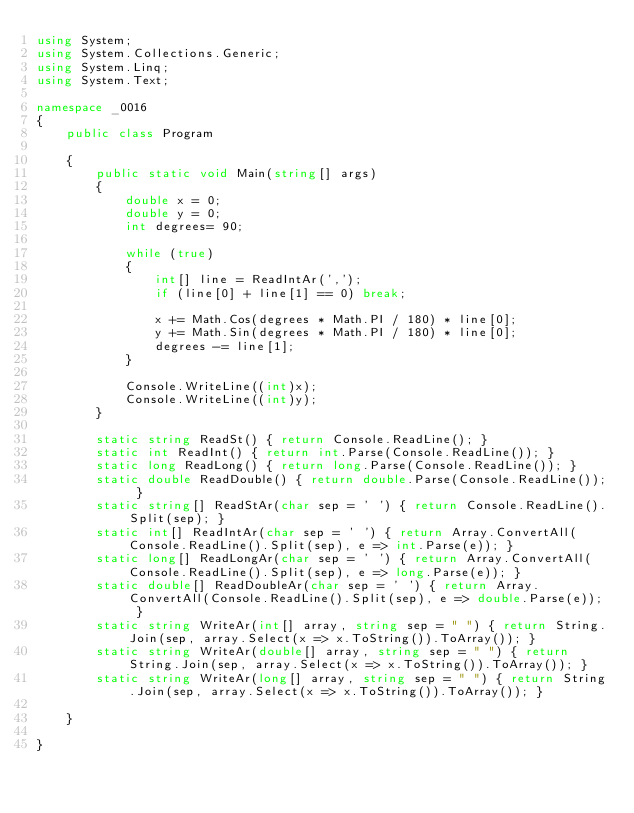<code> <loc_0><loc_0><loc_500><loc_500><_C#_>using System;
using System.Collections.Generic;
using System.Linq;
using System.Text;

namespace _0016
{
    public class Program

    {
        public static void Main(string[] args)
        {
            double x = 0;
            double y = 0;
            int degrees= 90;

            while (true)
            {
                int[] line = ReadIntAr(',');
                if (line[0] + line[1] == 0) break;

                x += Math.Cos(degrees * Math.PI / 180) * line[0];
                y += Math.Sin(degrees * Math.PI / 180) * line[0];
                degrees -= line[1];
            }

            Console.WriteLine((int)x);
            Console.WriteLine((int)y);
        }

        static string ReadSt() { return Console.ReadLine(); }
        static int ReadInt() { return int.Parse(Console.ReadLine()); }
        static long ReadLong() { return long.Parse(Console.ReadLine()); }
        static double ReadDouble() { return double.Parse(Console.ReadLine()); }
        static string[] ReadStAr(char sep = ' ') { return Console.ReadLine().Split(sep); }
        static int[] ReadIntAr(char sep = ' ') { return Array.ConvertAll(Console.ReadLine().Split(sep), e => int.Parse(e)); }
        static long[] ReadLongAr(char sep = ' ') { return Array.ConvertAll(Console.ReadLine().Split(sep), e => long.Parse(e)); }
        static double[] ReadDoubleAr(char sep = ' ') { return Array.ConvertAll(Console.ReadLine().Split(sep), e => double.Parse(e)); }
        static string WriteAr(int[] array, string sep = " ") { return String.Join(sep, array.Select(x => x.ToString()).ToArray()); }
        static string WriteAr(double[] array, string sep = " ") { return String.Join(sep, array.Select(x => x.ToString()).ToArray()); }
        static string WriteAr(long[] array, string sep = " ") { return String.Join(sep, array.Select(x => x.ToString()).ToArray()); }

    }

}

</code> 